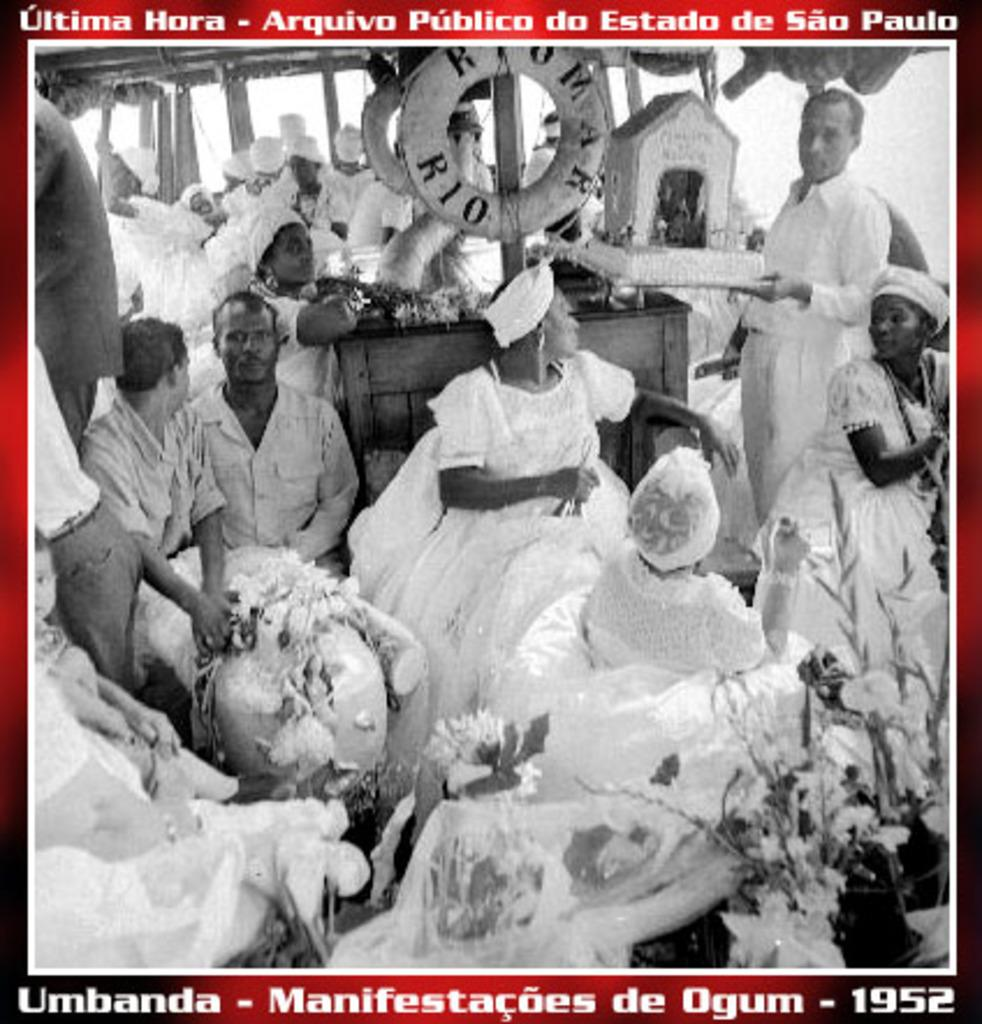What is the main subject of the poster in the image? The poster contains images of birds, tubes, flowers, and objects. Can you describe the images on the poster? The poster contains images of birds, tubes, flowers, and objects. Where is the text located on the poster? There is text at the top and bottom of the image. What type of stick can be seen providing pleasure to the birds in the image? There is no stick or indication of pleasure in the image; it only contains images of birds, tubes, flowers, and objects. What shape is the square object on the poster? There is no square object present in the image. 